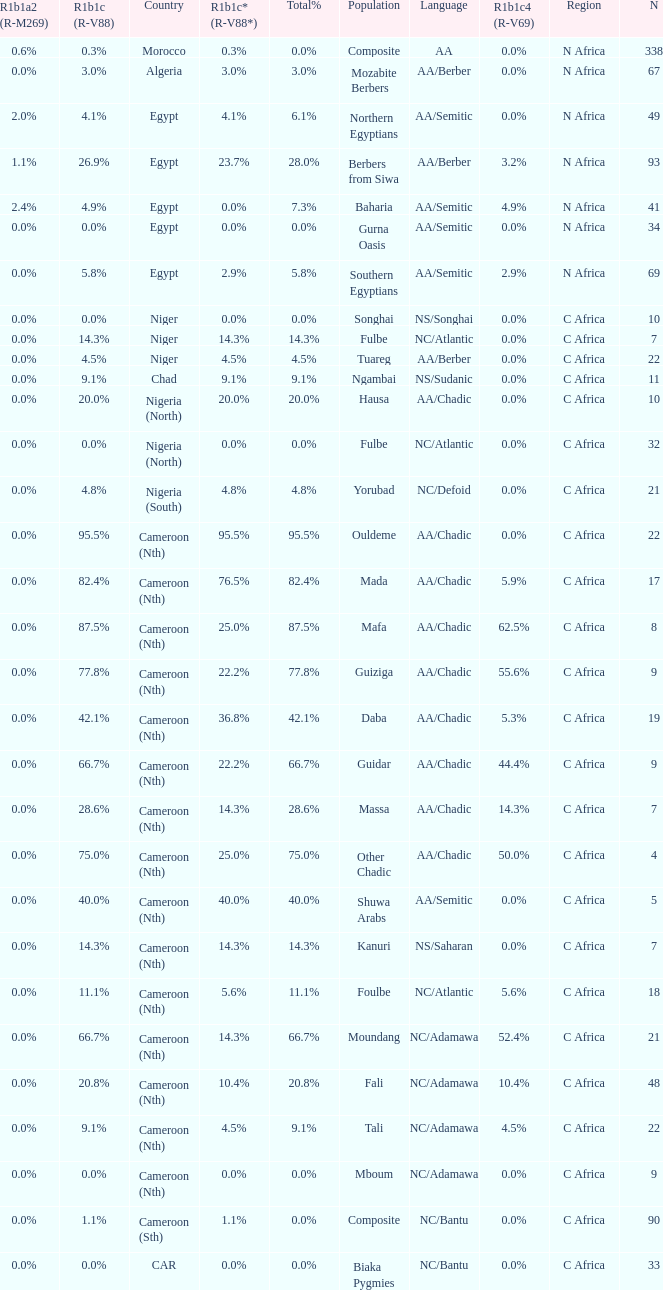How many n are listed for 0.6% r1b1a2 (r-m269)? 1.0. 